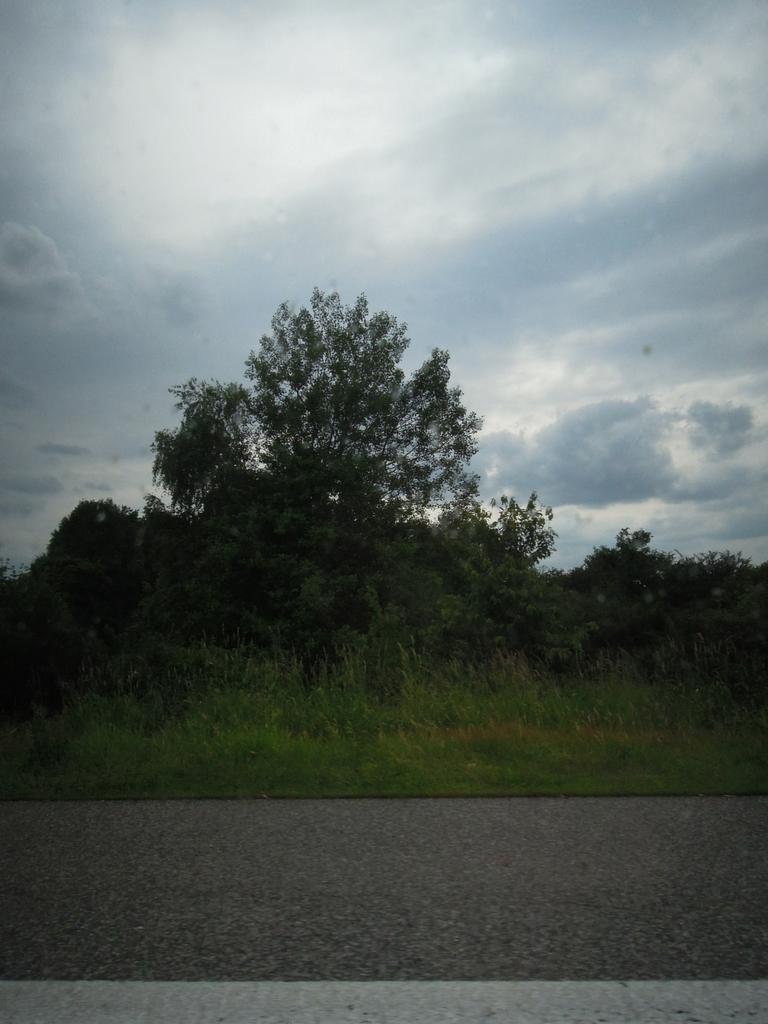Can you describe this image briefly? There is a road. Near to the road there are plants and trees. In the background there is sky with clouds. 